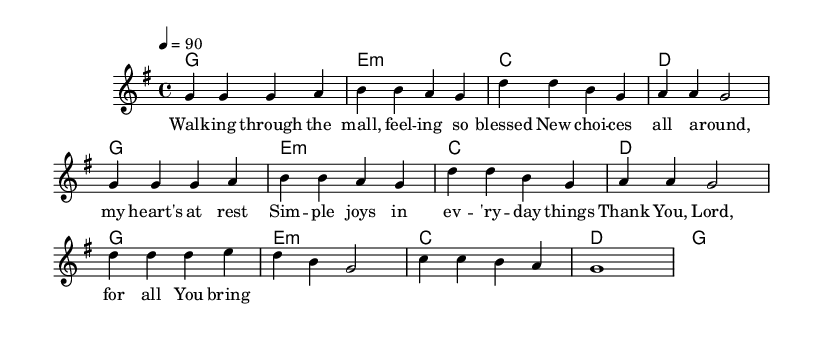What is the key signature of this music? The key signature is G major, which has one sharp (F#) indicated in the score.
Answer: G major What is the time signature of this music? The time signature shown in the score is 4/4, which signifies four beats per measure.
Answer: 4/4 What is the tempo marking for this piece? The tempo marking is quarter note equals 90, indicating the speed of the piece.
Answer: quarter note equals 90 How many measures are in the melody section? The melody section consists of eight measures as counted from the start of the melody to the end.
Answer: eight What do the lyrics primarily express? The lyrics express gratitude and recognition for simple joys and blessings in everyday life.
Answer: gratitude for blessings How many chords are used in the harmonies? There are four distinct chords used throughout the score: G, E minor, C, and D.
Answer: four What is the main theme of the lyrical content? The main theme revolves around finding joy and blessings in daily experiences.
Answer: joy in daily experiences 